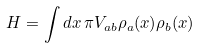Convert formula to latex. <formula><loc_0><loc_0><loc_500><loc_500>H = \int d x \, \pi V _ { a b } \rho _ { a } ( x ) \rho _ { b } ( x )</formula> 